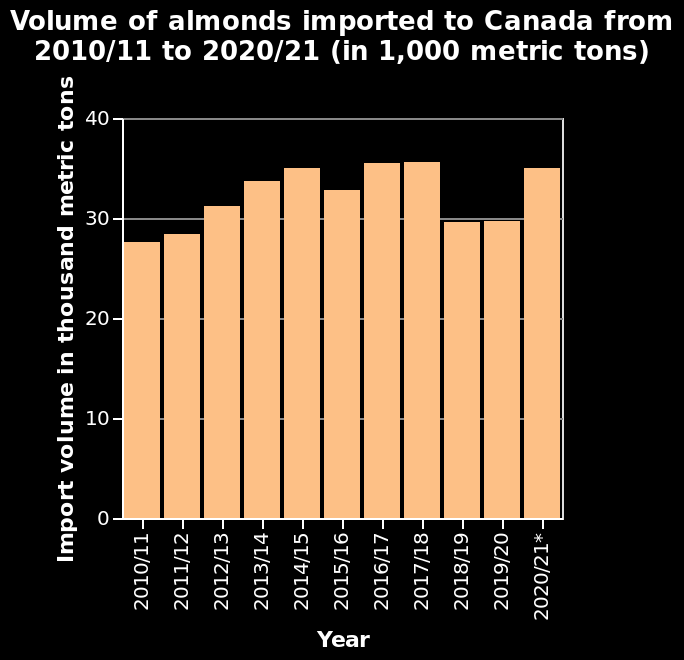<image>
Did the volume of almonds that Canada imported increase or decrease from 2010 to 2015? The volume of almonds that Canada imported increased every year from 2010 to 2015. 